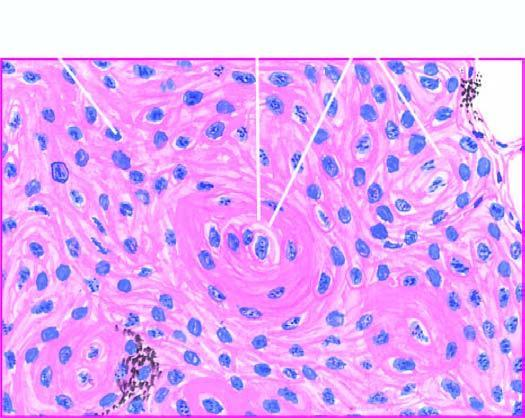re islands of invading malignant squamous cells seen?
Answer the question using a single word or phrase. Yes 